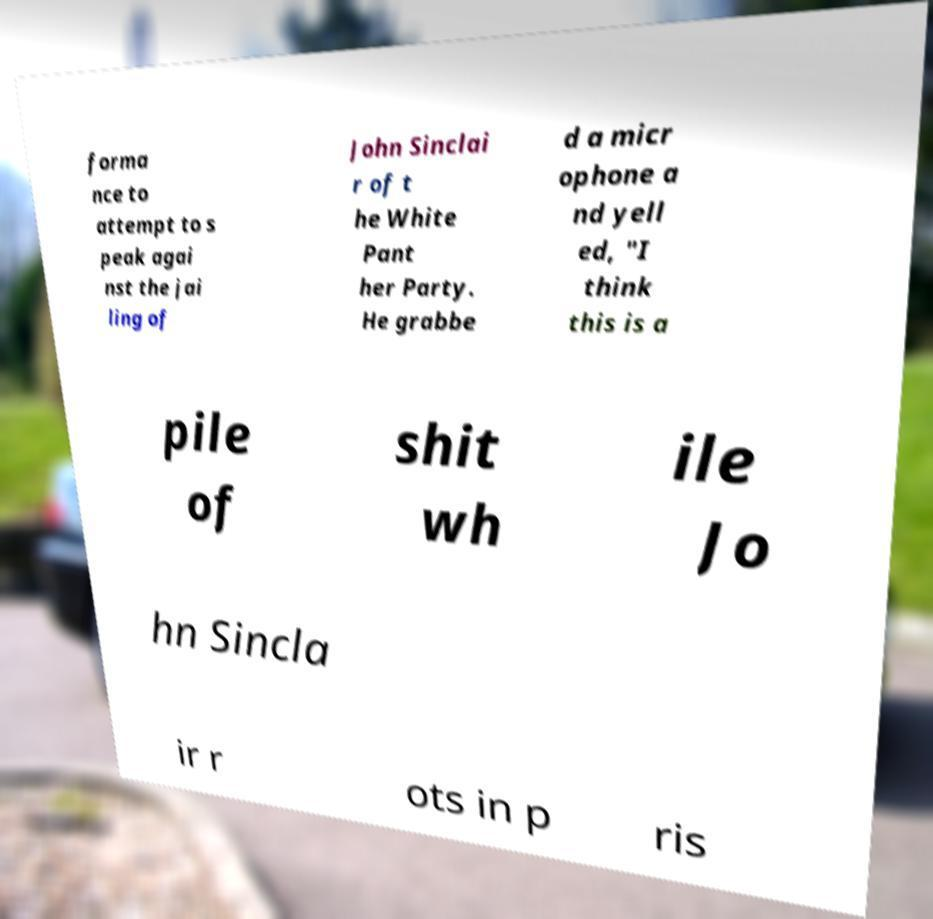There's text embedded in this image that I need extracted. Can you transcribe it verbatim? forma nce to attempt to s peak agai nst the jai ling of John Sinclai r of t he White Pant her Party. He grabbe d a micr ophone a nd yell ed, "I think this is a pile of shit wh ile Jo hn Sincla ir r ots in p ris 